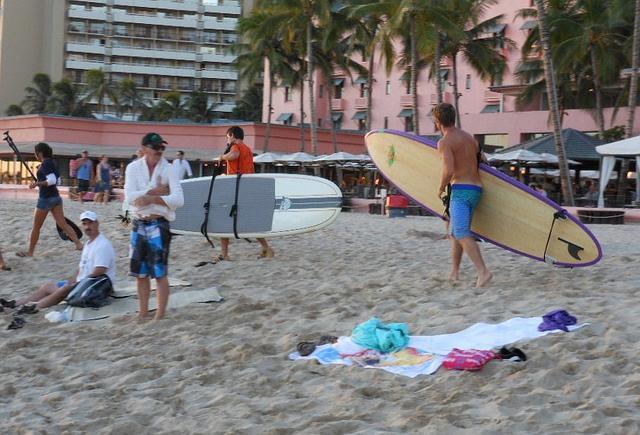What type of trees can be seen near the pink building?
Select the accurate response from the four choices given to answer the question.
Options: Maple trees, pine trees, elm trees, palm trees. Palm trees. 